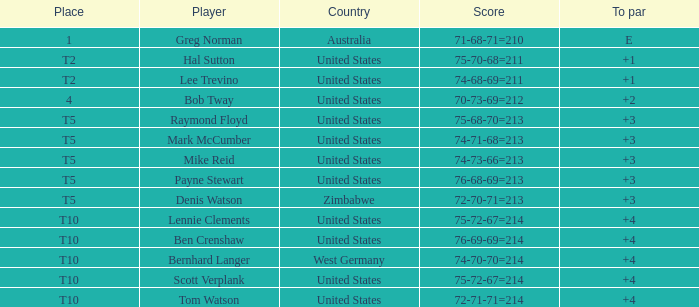Identify the u.s. player who has achieved a 75-70-68=211 score. Hal Sutton. 